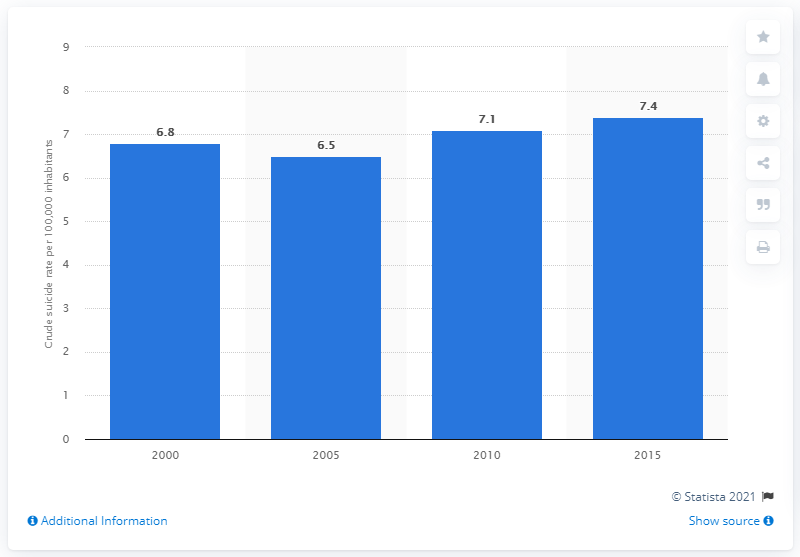Outline some significant characteristics in this image. The crude suicide rate in Vietnam in 2015 was 7.4 per 100,000 population. 